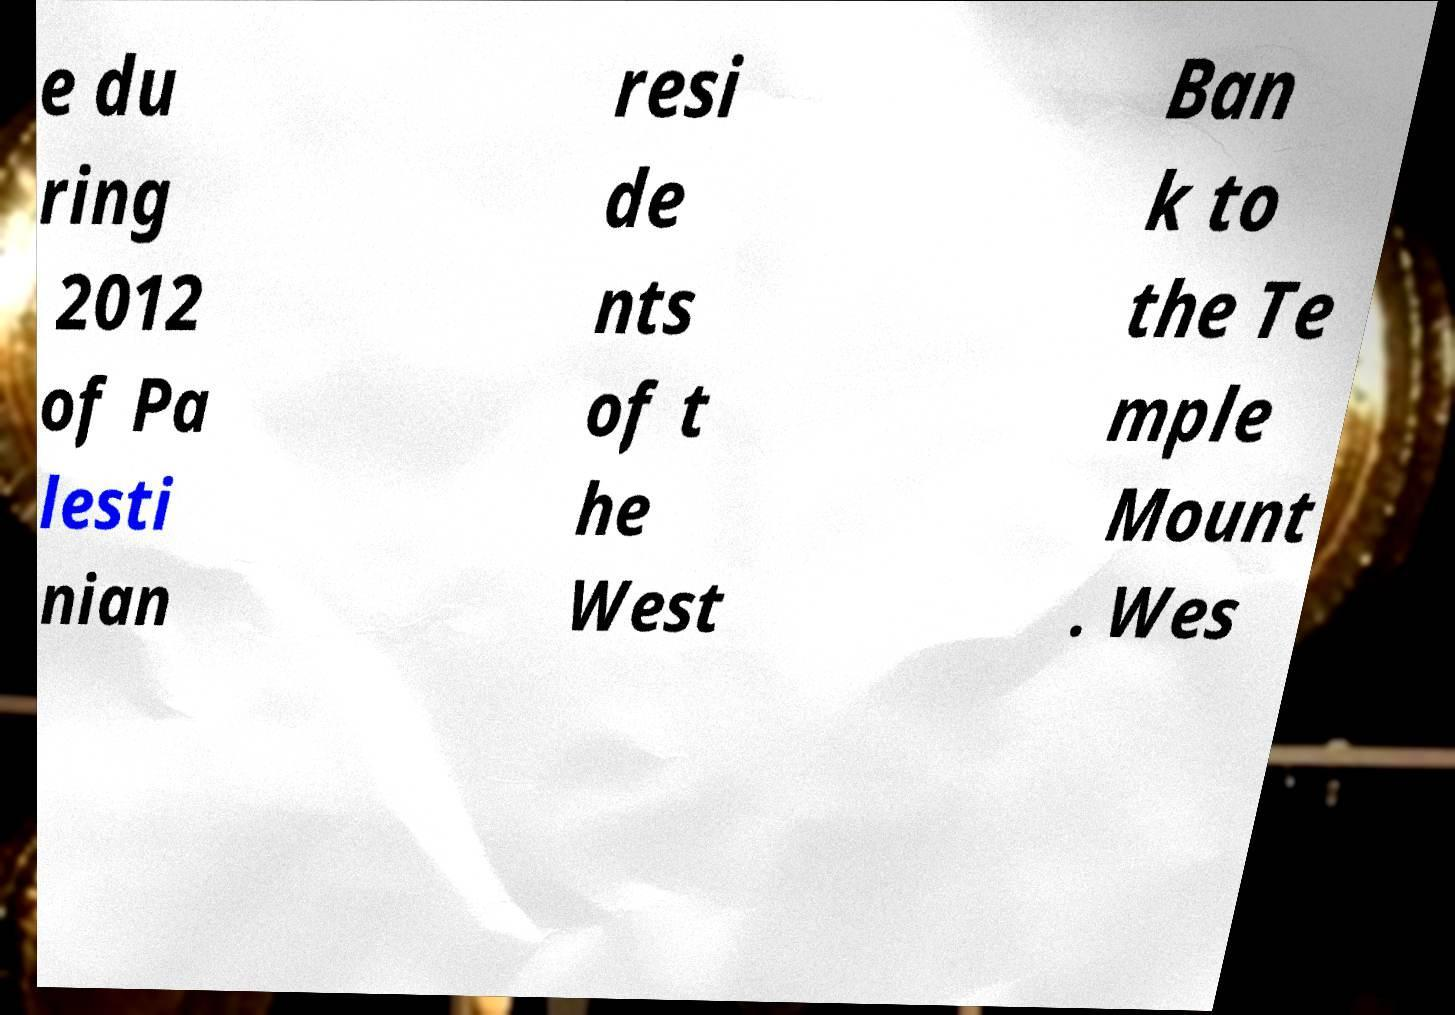Could you extract and type out the text from this image? e du ring 2012 of Pa lesti nian resi de nts of t he West Ban k to the Te mple Mount . Wes 